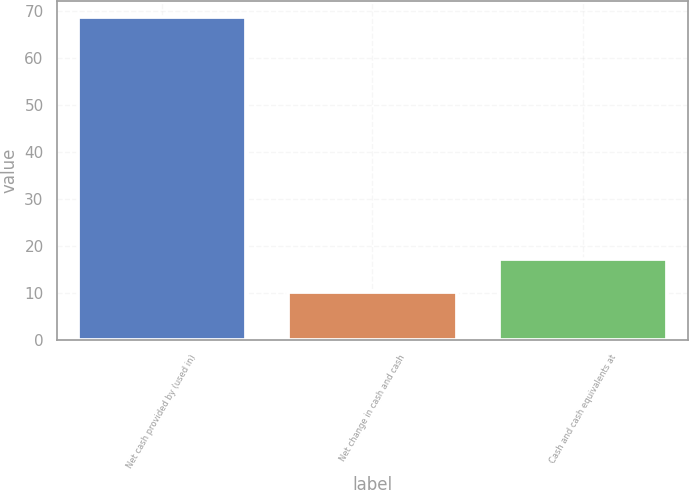Convert chart to OTSL. <chart><loc_0><loc_0><loc_500><loc_500><bar_chart><fcel>Net cash provided by (used in)<fcel>Net change in cash and cash<fcel>Cash and cash equivalents at<nl><fcel>68.8<fcel>10.3<fcel>17.28<nl></chart> 